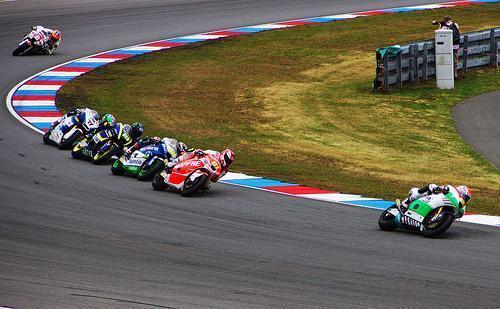How many bike?
Give a very brief answer. 6. How many motorcyles are behind the red motorcycle?
Give a very brief answer. 4. 